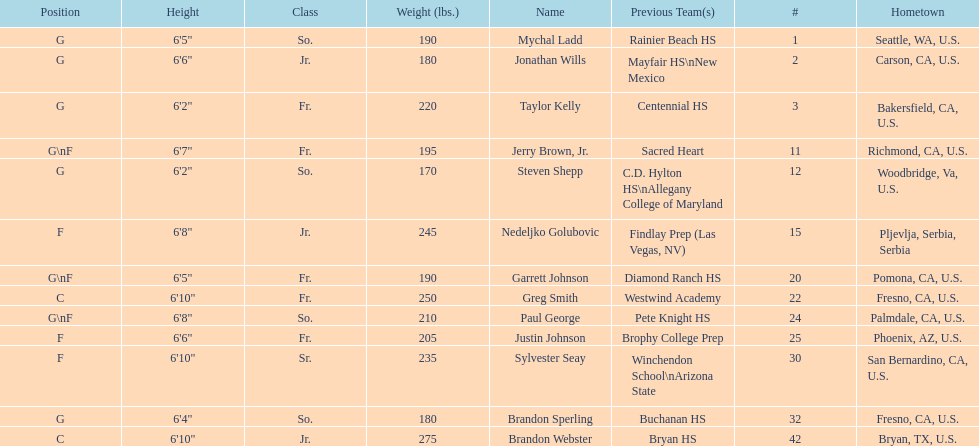Who is the only player not from the u. s.? Nedeljko Golubovic. 